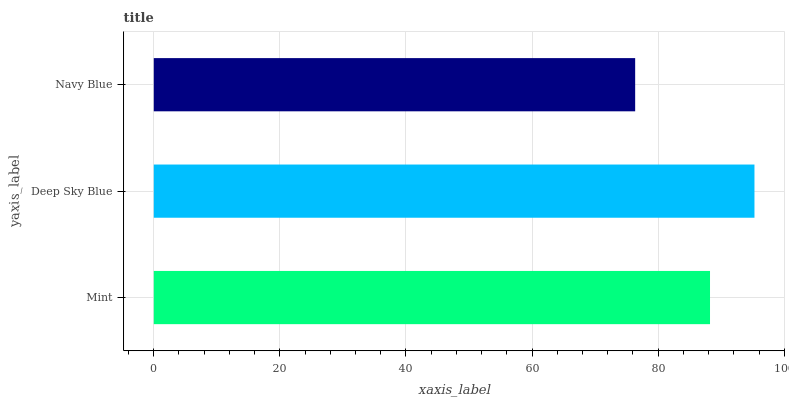Is Navy Blue the minimum?
Answer yes or no. Yes. Is Deep Sky Blue the maximum?
Answer yes or no. Yes. Is Deep Sky Blue the minimum?
Answer yes or no. No. Is Navy Blue the maximum?
Answer yes or no. No. Is Deep Sky Blue greater than Navy Blue?
Answer yes or no. Yes. Is Navy Blue less than Deep Sky Blue?
Answer yes or no. Yes. Is Navy Blue greater than Deep Sky Blue?
Answer yes or no. No. Is Deep Sky Blue less than Navy Blue?
Answer yes or no. No. Is Mint the high median?
Answer yes or no. Yes. Is Mint the low median?
Answer yes or no. Yes. Is Navy Blue the high median?
Answer yes or no. No. Is Deep Sky Blue the low median?
Answer yes or no. No. 